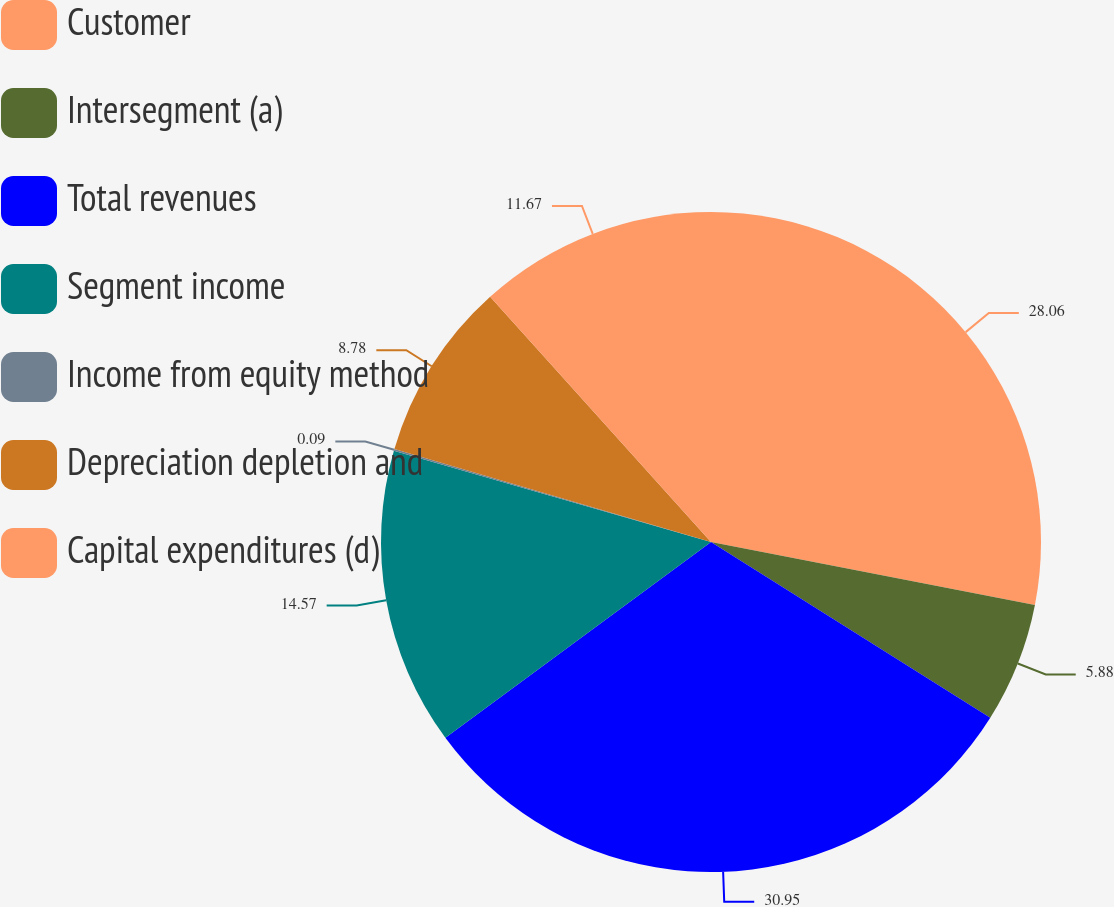Convert chart. <chart><loc_0><loc_0><loc_500><loc_500><pie_chart><fcel>Customer<fcel>Intersegment (a)<fcel>Total revenues<fcel>Segment income<fcel>Income from equity method<fcel>Depreciation depletion and<fcel>Capital expenditures (d)<nl><fcel>28.06%<fcel>5.88%<fcel>30.95%<fcel>14.57%<fcel>0.09%<fcel>8.78%<fcel>11.67%<nl></chart> 